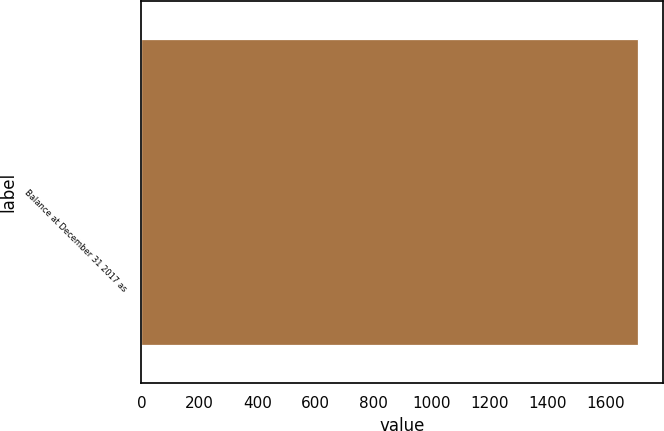Convert chart to OTSL. <chart><loc_0><loc_0><loc_500><loc_500><bar_chart><fcel>Balance at December 31 2017 as<nl><fcel>1713<nl></chart> 